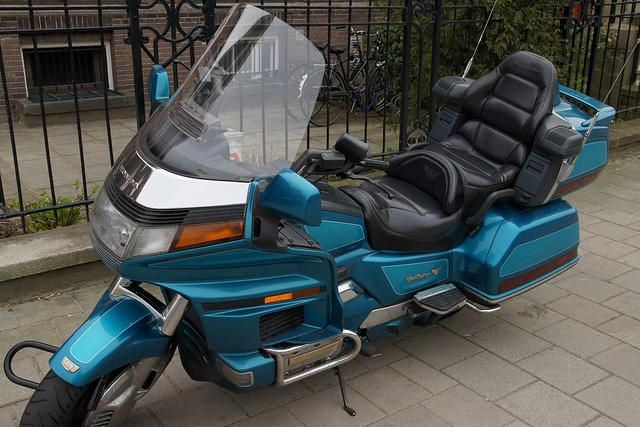How many people can ride this motorcycle at a time?

Choices:
A) four
B) two
C) three
D) one two 